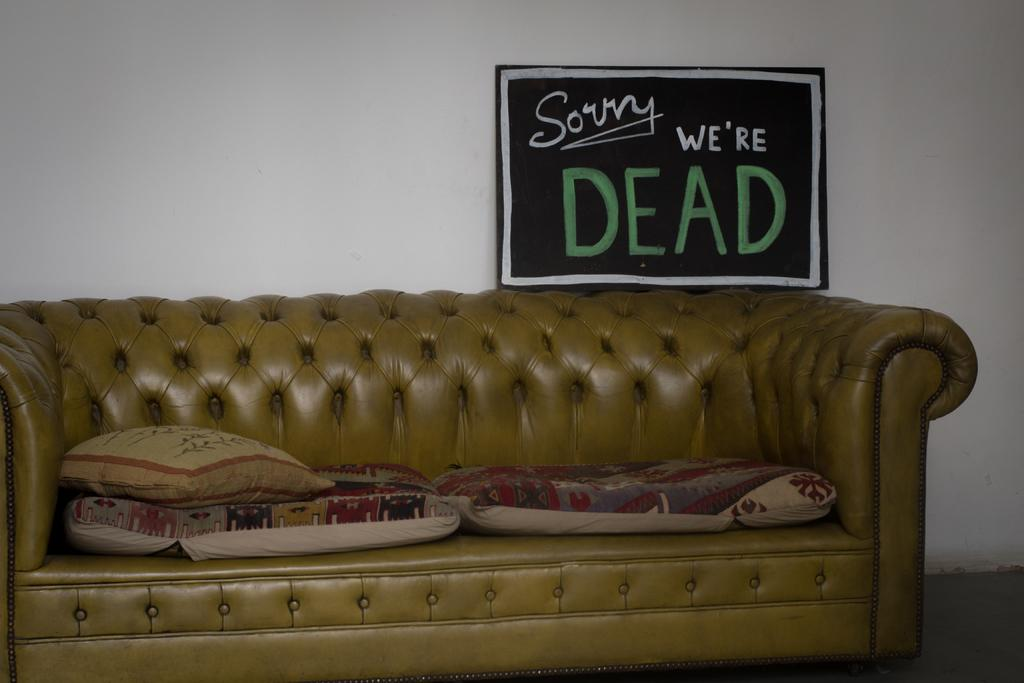What type of furniture is in the image? There is a couch in the image. What is on the couch? There are pillows on the couch. What can be seen on the wall? There is a poster on a wall. What type of wire is visible on the poster? There is no wire visible on the poster in the image. What type of underwear is visible on the couch? There is no underwear visible on the couch in the image. 